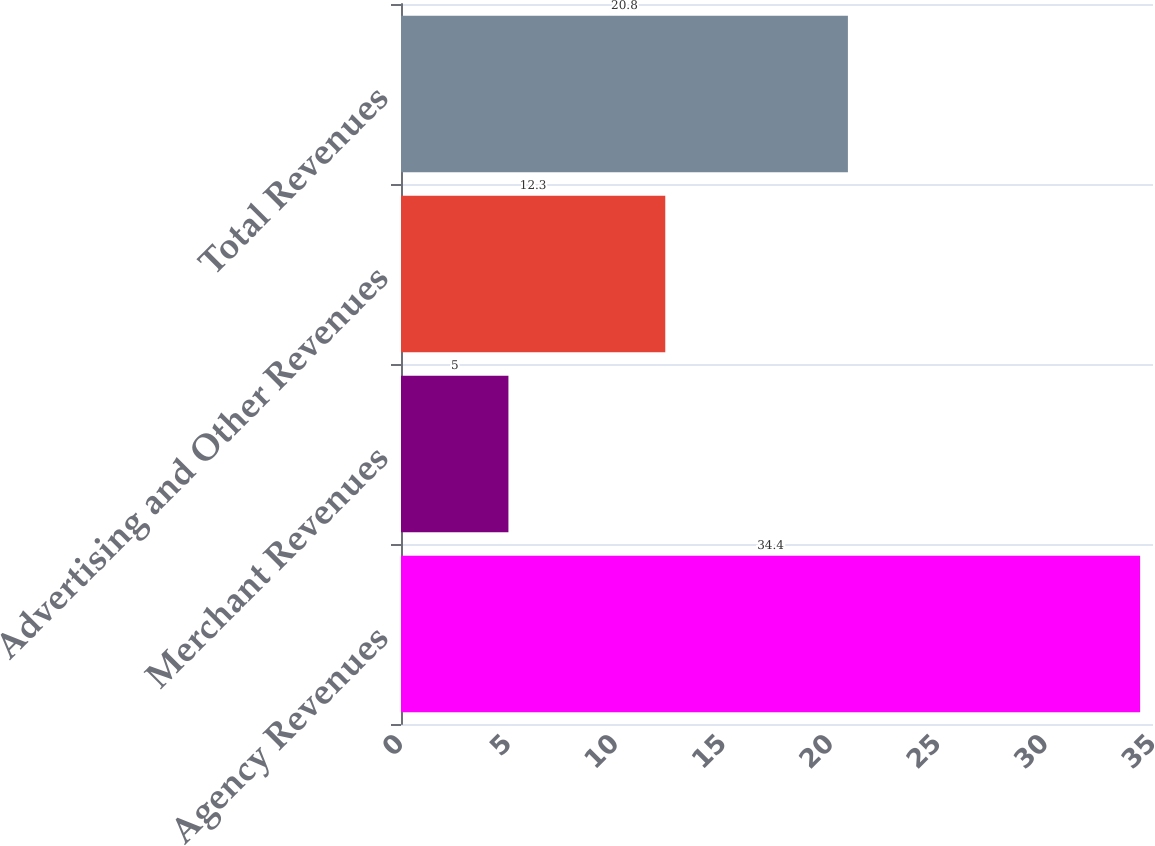<chart> <loc_0><loc_0><loc_500><loc_500><bar_chart><fcel>Agency Revenues<fcel>Merchant Revenues<fcel>Advertising and Other Revenues<fcel>Total Revenues<nl><fcel>34.4<fcel>5<fcel>12.3<fcel>20.8<nl></chart> 